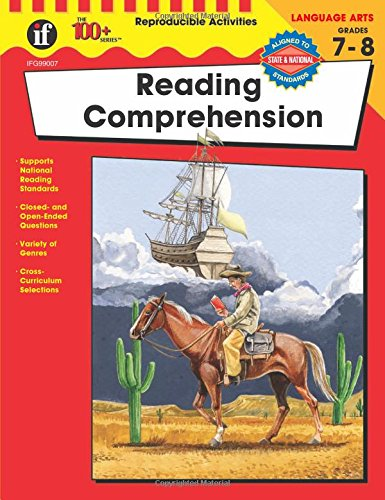Is this book related to Teen & Young Adult? Yes, this book is particularly geared towards teenagers and young adults, aiming to develop critical reading skills appropriate for students in grades 7 and 8. 